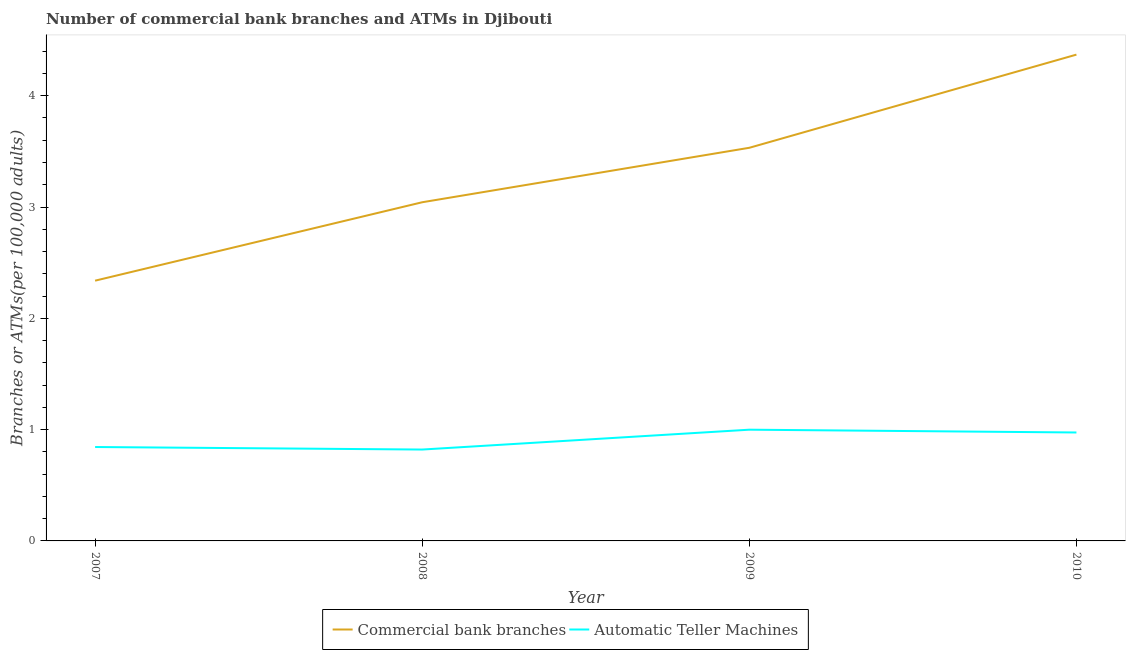How many different coloured lines are there?
Your response must be concise. 2. Is the number of lines equal to the number of legend labels?
Your answer should be compact. Yes. What is the number of atms in 2007?
Provide a succinct answer. 0.84. Across all years, what is the maximum number of commercal bank branches?
Your response must be concise. 4.37. Across all years, what is the minimum number of commercal bank branches?
Keep it short and to the point. 2.34. What is the total number of atms in the graph?
Your answer should be very brief. 3.64. What is the difference between the number of commercal bank branches in 2008 and that in 2009?
Make the answer very short. -0.49. What is the difference between the number of atms in 2008 and the number of commercal bank branches in 2007?
Provide a short and direct response. -1.52. What is the average number of atms per year?
Offer a very short reply. 0.91. In the year 2007, what is the difference between the number of atms and number of commercal bank branches?
Offer a very short reply. -1.49. In how many years, is the number of commercal bank branches greater than 4?
Ensure brevity in your answer.  1. What is the ratio of the number of atms in 2007 to that in 2010?
Your answer should be very brief. 0.87. Is the number of atms in 2007 less than that in 2009?
Keep it short and to the point. Yes. Is the difference between the number of commercal bank branches in 2007 and 2009 greater than the difference between the number of atms in 2007 and 2009?
Provide a short and direct response. No. What is the difference between the highest and the second highest number of commercal bank branches?
Offer a very short reply. 0.84. What is the difference between the highest and the lowest number of commercal bank branches?
Your answer should be very brief. 2.03. Does the number of commercal bank branches monotonically increase over the years?
Offer a terse response. Yes. Is the number of atms strictly greater than the number of commercal bank branches over the years?
Your response must be concise. No. Is the number of atms strictly less than the number of commercal bank branches over the years?
Ensure brevity in your answer.  Yes. Are the values on the major ticks of Y-axis written in scientific E-notation?
Provide a succinct answer. No. Does the graph contain grids?
Give a very brief answer. No. Where does the legend appear in the graph?
Give a very brief answer. Bottom center. How many legend labels are there?
Offer a terse response. 2. How are the legend labels stacked?
Provide a short and direct response. Horizontal. What is the title of the graph?
Offer a very short reply. Number of commercial bank branches and ATMs in Djibouti. Does "Official aid received" appear as one of the legend labels in the graph?
Offer a terse response. No. What is the label or title of the X-axis?
Provide a short and direct response. Year. What is the label or title of the Y-axis?
Your response must be concise. Branches or ATMs(per 100,0 adults). What is the Branches or ATMs(per 100,000 adults) of Commercial bank branches in 2007?
Your response must be concise. 2.34. What is the Branches or ATMs(per 100,000 adults) of Automatic Teller Machines in 2007?
Your response must be concise. 0.84. What is the Branches or ATMs(per 100,000 adults) of Commercial bank branches in 2008?
Give a very brief answer. 3.04. What is the Branches or ATMs(per 100,000 adults) of Automatic Teller Machines in 2008?
Provide a short and direct response. 0.82. What is the Branches or ATMs(per 100,000 adults) of Commercial bank branches in 2009?
Your response must be concise. 3.53. What is the Branches or ATMs(per 100,000 adults) of Automatic Teller Machines in 2009?
Offer a terse response. 1. What is the Branches or ATMs(per 100,000 adults) in Commercial bank branches in 2010?
Offer a terse response. 4.37. What is the Branches or ATMs(per 100,000 adults) of Automatic Teller Machines in 2010?
Provide a succinct answer. 0.97. Across all years, what is the maximum Branches or ATMs(per 100,000 adults) in Commercial bank branches?
Your answer should be very brief. 4.37. Across all years, what is the maximum Branches or ATMs(per 100,000 adults) in Automatic Teller Machines?
Offer a very short reply. 1. Across all years, what is the minimum Branches or ATMs(per 100,000 adults) in Commercial bank branches?
Make the answer very short. 2.34. Across all years, what is the minimum Branches or ATMs(per 100,000 adults) in Automatic Teller Machines?
Provide a short and direct response. 0.82. What is the total Branches or ATMs(per 100,000 adults) in Commercial bank branches in the graph?
Your response must be concise. 13.28. What is the total Branches or ATMs(per 100,000 adults) in Automatic Teller Machines in the graph?
Provide a short and direct response. 3.64. What is the difference between the Branches or ATMs(per 100,000 adults) of Commercial bank branches in 2007 and that in 2008?
Provide a short and direct response. -0.7. What is the difference between the Branches or ATMs(per 100,000 adults) in Automatic Teller Machines in 2007 and that in 2008?
Your response must be concise. 0.02. What is the difference between the Branches or ATMs(per 100,000 adults) of Commercial bank branches in 2007 and that in 2009?
Your response must be concise. -1.19. What is the difference between the Branches or ATMs(per 100,000 adults) of Automatic Teller Machines in 2007 and that in 2009?
Make the answer very short. -0.16. What is the difference between the Branches or ATMs(per 100,000 adults) in Commercial bank branches in 2007 and that in 2010?
Provide a short and direct response. -2.03. What is the difference between the Branches or ATMs(per 100,000 adults) of Automatic Teller Machines in 2007 and that in 2010?
Provide a short and direct response. -0.13. What is the difference between the Branches or ATMs(per 100,000 adults) in Commercial bank branches in 2008 and that in 2009?
Give a very brief answer. -0.49. What is the difference between the Branches or ATMs(per 100,000 adults) in Automatic Teller Machines in 2008 and that in 2009?
Offer a terse response. -0.18. What is the difference between the Branches or ATMs(per 100,000 adults) of Commercial bank branches in 2008 and that in 2010?
Your answer should be very brief. -1.33. What is the difference between the Branches or ATMs(per 100,000 adults) in Automatic Teller Machines in 2008 and that in 2010?
Provide a succinct answer. -0.15. What is the difference between the Branches or ATMs(per 100,000 adults) in Commercial bank branches in 2009 and that in 2010?
Your answer should be very brief. -0.84. What is the difference between the Branches or ATMs(per 100,000 adults) of Automatic Teller Machines in 2009 and that in 2010?
Your response must be concise. 0.03. What is the difference between the Branches or ATMs(per 100,000 adults) in Commercial bank branches in 2007 and the Branches or ATMs(per 100,000 adults) in Automatic Teller Machines in 2008?
Provide a succinct answer. 1.52. What is the difference between the Branches or ATMs(per 100,000 adults) of Commercial bank branches in 2007 and the Branches or ATMs(per 100,000 adults) of Automatic Teller Machines in 2009?
Make the answer very short. 1.34. What is the difference between the Branches or ATMs(per 100,000 adults) in Commercial bank branches in 2007 and the Branches or ATMs(per 100,000 adults) in Automatic Teller Machines in 2010?
Your answer should be compact. 1.36. What is the difference between the Branches or ATMs(per 100,000 adults) in Commercial bank branches in 2008 and the Branches or ATMs(per 100,000 adults) in Automatic Teller Machines in 2009?
Provide a succinct answer. 2.04. What is the difference between the Branches or ATMs(per 100,000 adults) of Commercial bank branches in 2008 and the Branches or ATMs(per 100,000 adults) of Automatic Teller Machines in 2010?
Provide a succinct answer. 2.07. What is the difference between the Branches or ATMs(per 100,000 adults) in Commercial bank branches in 2009 and the Branches or ATMs(per 100,000 adults) in Automatic Teller Machines in 2010?
Give a very brief answer. 2.56. What is the average Branches or ATMs(per 100,000 adults) of Commercial bank branches per year?
Your answer should be compact. 3.32. What is the average Branches or ATMs(per 100,000 adults) of Automatic Teller Machines per year?
Provide a succinct answer. 0.91. In the year 2007, what is the difference between the Branches or ATMs(per 100,000 adults) in Commercial bank branches and Branches or ATMs(per 100,000 adults) in Automatic Teller Machines?
Your response must be concise. 1.49. In the year 2008, what is the difference between the Branches or ATMs(per 100,000 adults) in Commercial bank branches and Branches or ATMs(per 100,000 adults) in Automatic Teller Machines?
Your answer should be very brief. 2.22. In the year 2009, what is the difference between the Branches or ATMs(per 100,000 adults) of Commercial bank branches and Branches or ATMs(per 100,000 adults) of Automatic Teller Machines?
Offer a very short reply. 2.53. In the year 2010, what is the difference between the Branches or ATMs(per 100,000 adults) of Commercial bank branches and Branches or ATMs(per 100,000 adults) of Automatic Teller Machines?
Ensure brevity in your answer.  3.39. What is the ratio of the Branches or ATMs(per 100,000 adults) in Commercial bank branches in 2007 to that in 2008?
Your answer should be very brief. 0.77. What is the ratio of the Branches or ATMs(per 100,000 adults) of Automatic Teller Machines in 2007 to that in 2008?
Your response must be concise. 1.03. What is the ratio of the Branches or ATMs(per 100,000 adults) in Commercial bank branches in 2007 to that in 2009?
Your response must be concise. 0.66. What is the ratio of the Branches or ATMs(per 100,000 adults) of Automatic Teller Machines in 2007 to that in 2009?
Your answer should be very brief. 0.84. What is the ratio of the Branches or ATMs(per 100,000 adults) in Commercial bank branches in 2007 to that in 2010?
Your answer should be very brief. 0.54. What is the ratio of the Branches or ATMs(per 100,000 adults) of Automatic Teller Machines in 2007 to that in 2010?
Offer a terse response. 0.87. What is the ratio of the Branches or ATMs(per 100,000 adults) in Commercial bank branches in 2008 to that in 2009?
Your answer should be very brief. 0.86. What is the ratio of the Branches or ATMs(per 100,000 adults) in Automatic Teller Machines in 2008 to that in 2009?
Provide a succinct answer. 0.82. What is the ratio of the Branches or ATMs(per 100,000 adults) in Commercial bank branches in 2008 to that in 2010?
Make the answer very short. 0.7. What is the ratio of the Branches or ATMs(per 100,000 adults) in Automatic Teller Machines in 2008 to that in 2010?
Provide a short and direct response. 0.84. What is the ratio of the Branches or ATMs(per 100,000 adults) of Commercial bank branches in 2009 to that in 2010?
Your answer should be very brief. 0.81. What is the ratio of the Branches or ATMs(per 100,000 adults) of Automatic Teller Machines in 2009 to that in 2010?
Your answer should be compact. 1.03. What is the difference between the highest and the second highest Branches or ATMs(per 100,000 adults) in Commercial bank branches?
Provide a short and direct response. 0.84. What is the difference between the highest and the second highest Branches or ATMs(per 100,000 adults) in Automatic Teller Machines?
Provide a succinct answer. 0.03. What is the difference between the highest and the lowest Branches or ATMs(per 100,000 adults) in Commercial bank branches?
Provide a short and direct response. 2.03. What is the difference between the highest and the lowest Branches or ATMs(per 100,000 adults) of Automatic Teller Machines?
Your answer should be compact. 0.18. 